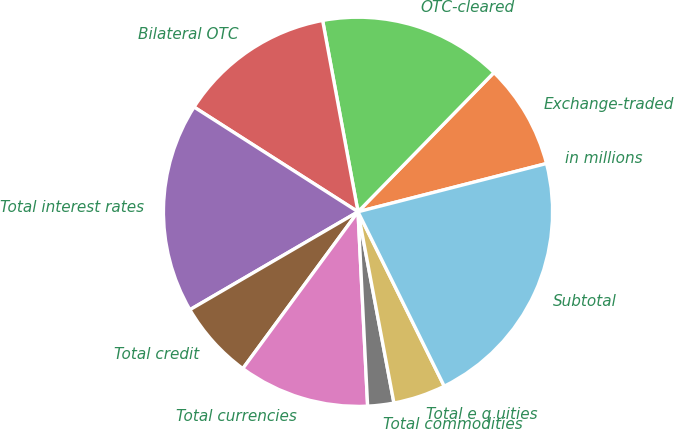Convert chart. <chart><loc_0><loc_0><loc_500><loc_500><pie_chart><fcel>in millions<fcel>Exchange-traded<fcel>OTC-cleared<fcel>Bilateral OTC<fcel>Total interest rates<fcel>Total credit<fcel>Total currencies<fcel>Total commodities<fcel>Total e q uities<fcel>Subtotal<nl><fcel>0.0%<fcel>8.7%<fcel>15.22%<fcel>13.04%<fcel>17.44%<fcel>6.52%<fcel>10.87%<fcel>2.17%<fcel>4.35%<fcel>21.68%<nl></chart> 